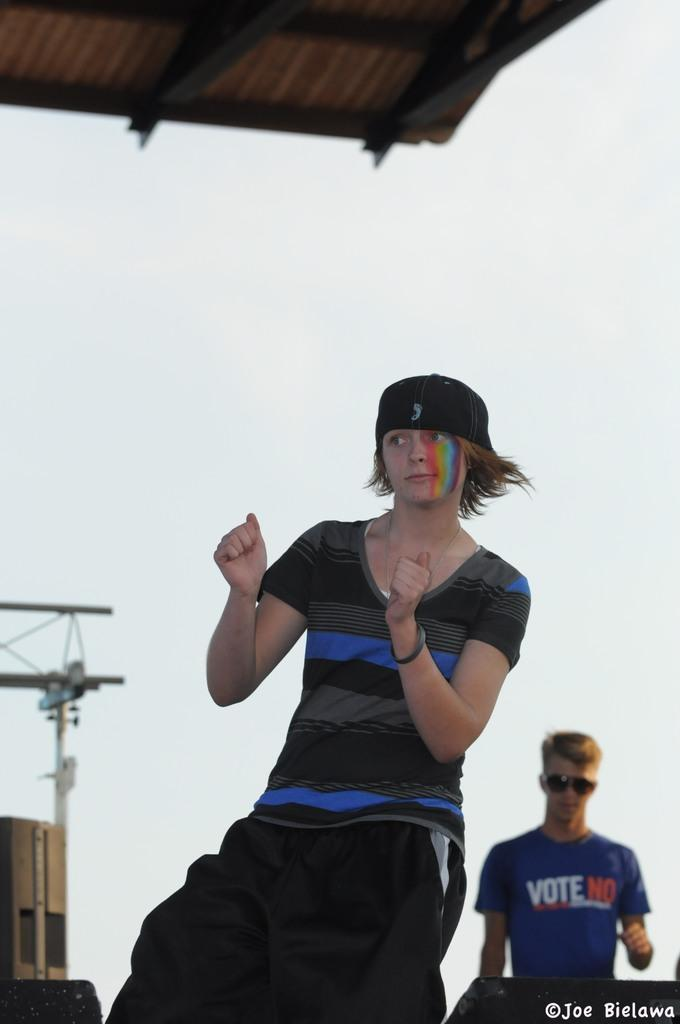Provide a one-sentence caption for the provided image. A girl is dancing on a stage in front of a boy with a shirt that says Vote No. 